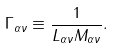Convert formula to latex. <formula><loc_0><loc_0><loc_500><loc_500>\Gamma _ { \alpha \nu } \equiv \frac { 1 } { L _ { \alpha \nu } M _ { \alpha \nu } } .</formula> 